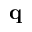Convert formula to latex. <formula><loc_0><loc_0><loc_500><loc_500>q</formula> 